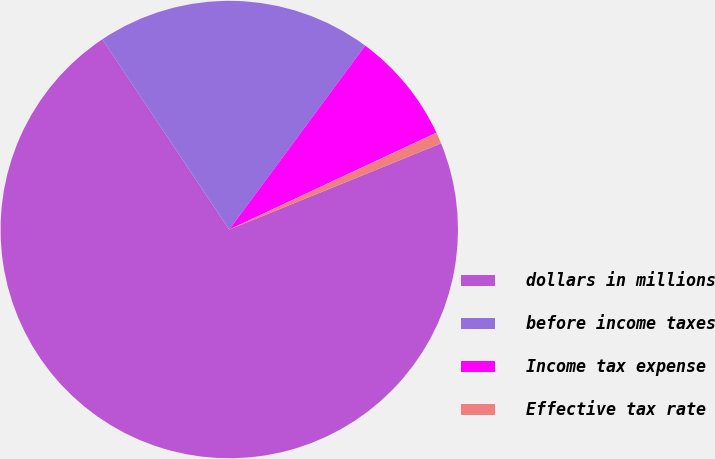<chart> <loc_0><loc_0><loc_500><loc_500><pie_chart><fcel>dollars in millions<fcel>before income taxes<fcel>Income tax expense<fcel>Effective tax rate<nl><fcel>71.79%<fcel>19.49%<fcel>7.91%<fcel>0.81%<nl></chart> 